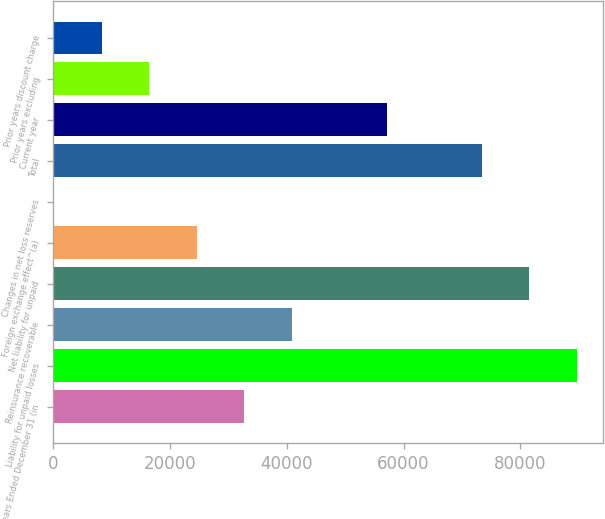<chart> <loc_0><loc_0><loc_500><loc_500><bar_chart><fcel>Years Ended December 31 (in<fcel>Liability for unpaid losses<fcel>Reinsurance recoverable<fcel>Net liability for unpaid<fcel>Foreign exchange effect^(a)<fcel>Changes in net loss reserves<fcel>Total<fcel>Current year<fcel>Prior years excluding<fcel>Prior years discount charge<nl><fcel>32703.4<fcel>89687.6<fcel>40844<fcel>81547<fcel>24562.8<fcel>141<fcel>73406.4<fcel>57125.2<fcel>16422.2<fcel>8281.6<nl></chart> 